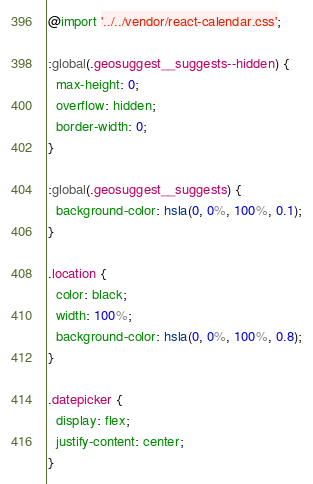<code> <loc_0><loc_0><loc_500><loc_500><_CSS_>@import '../../vendor/react-calendar.css';

:global(.geosuggest__suggests--hidden) {
  max-height: 0;
  overflow: hidden;
  border-width: 0;
}

:global(.geosuggest__suggests) {
  background-color: hsla(0, 0%, 100%, 0.1);
}

.location {
  color: black;
  width: 100%;
  background-color: hsla(0, 0%, 100%, 0.8);
}

.datepicker {
  display: flex;
  justify-content: center;
}
</code> 